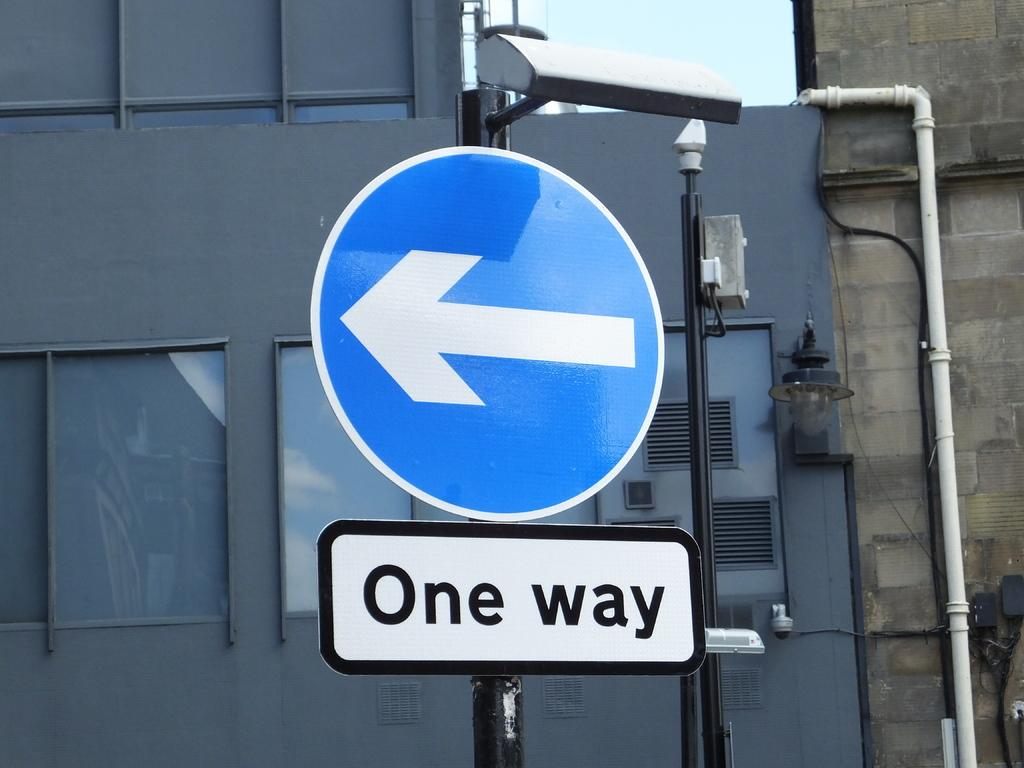<image>
Write a terse but informative summary of the picture. The blue sign has the writing One Way below it 